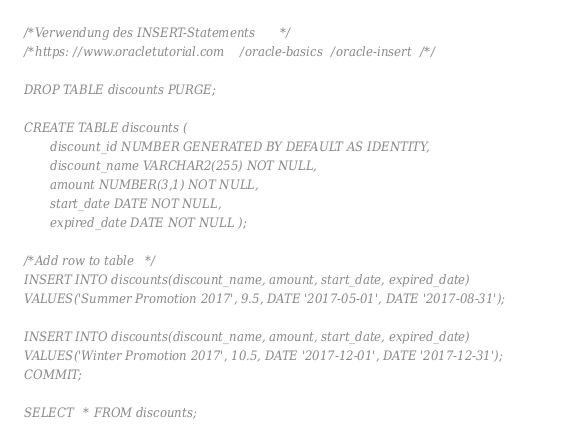Convert code to text. <code><loc_0><loc_0><loc_500><loc_500><_SQL_>/*Verwendung des INSERT-Statements*/
/*https://www.oracletutorial.com/oracle-basics/oracle-insert/*/

DROP TABLE discounts PURGE;

CREATE TABLE discounts (
       discount_id NUMBER GENERATED BY DEFAULT AS IDENTITY,
       discount_name VARCHAR2(255) NOT NULL,
       amount NUMBER(3,1) NOT NULL, 
       start_date DATE NOT NULL,
       expired_date DATE NOT NULL );

/*Add row to table*/
INSERT INTO discounts(discount_name, amount, start_date, expired_date)
VALUES('Summer Promotion 2017', 9.5, DATE '2017-05-01', DATE '2017-08-31');

INSERT INTO discounts(discount_name, amount, start_date, expired_date)
VALUES('Winter Promotion 2017', 10.5, DATE '2017-12-01', DATE '2017-12-31');
COMMIT;

SELECT * FROM discounts;
</code> 